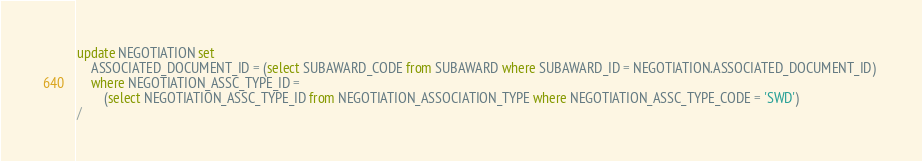<code> <loc_0><loc_0><loc_500><loc_500><_SQL_>update NEGOTIATION set 
	ASSOCIATED_DOCUMENT_ID = (select SUBAWARD_CODE from SUBAWARD where SUBAWARD_ID = NEGOTIATION.ASSOCIATED_DOCUMENT_ID) 
	where NEGOTIATION_ASSC_TYPE_ID = 
		(select NEGOTIATION_ASSC_TYPE_ID from NEGOTIATION_ASSOCIATION_TYPE where NEGOTIATION_ASSC_TYPE_CODE = 'SWD')
/
</code> 